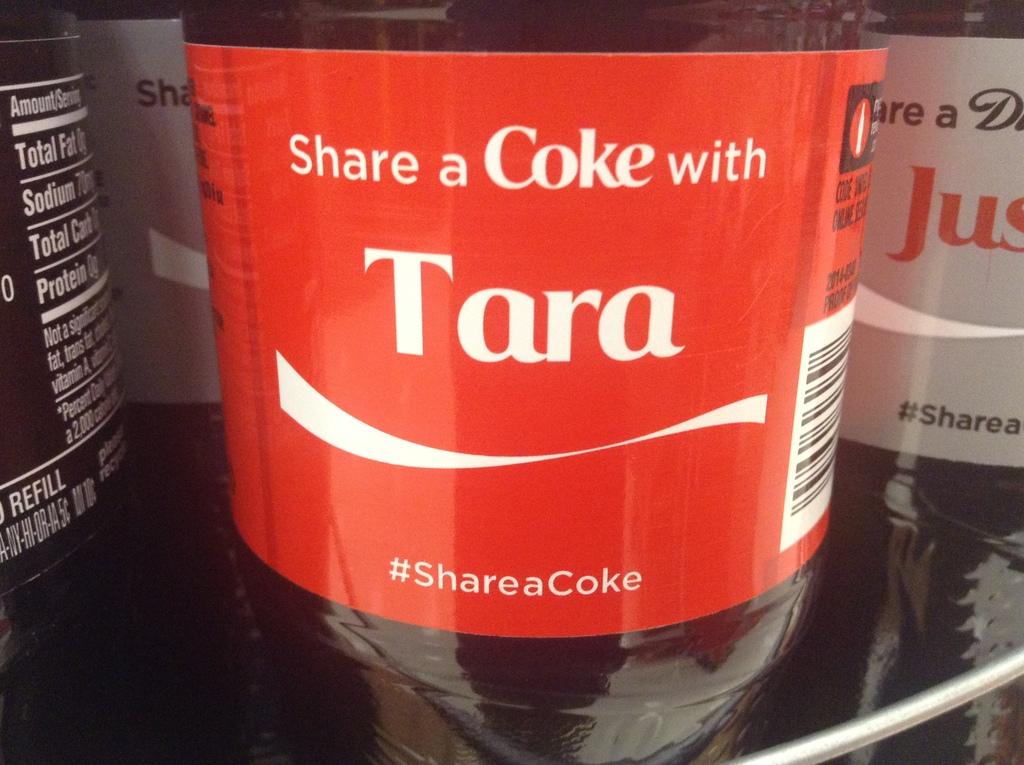What is the hashtag of the coke campaign?
Provide a short and direct response. #shareacoke. What's the name on the bottle?
Make the answer very short. Tara. 